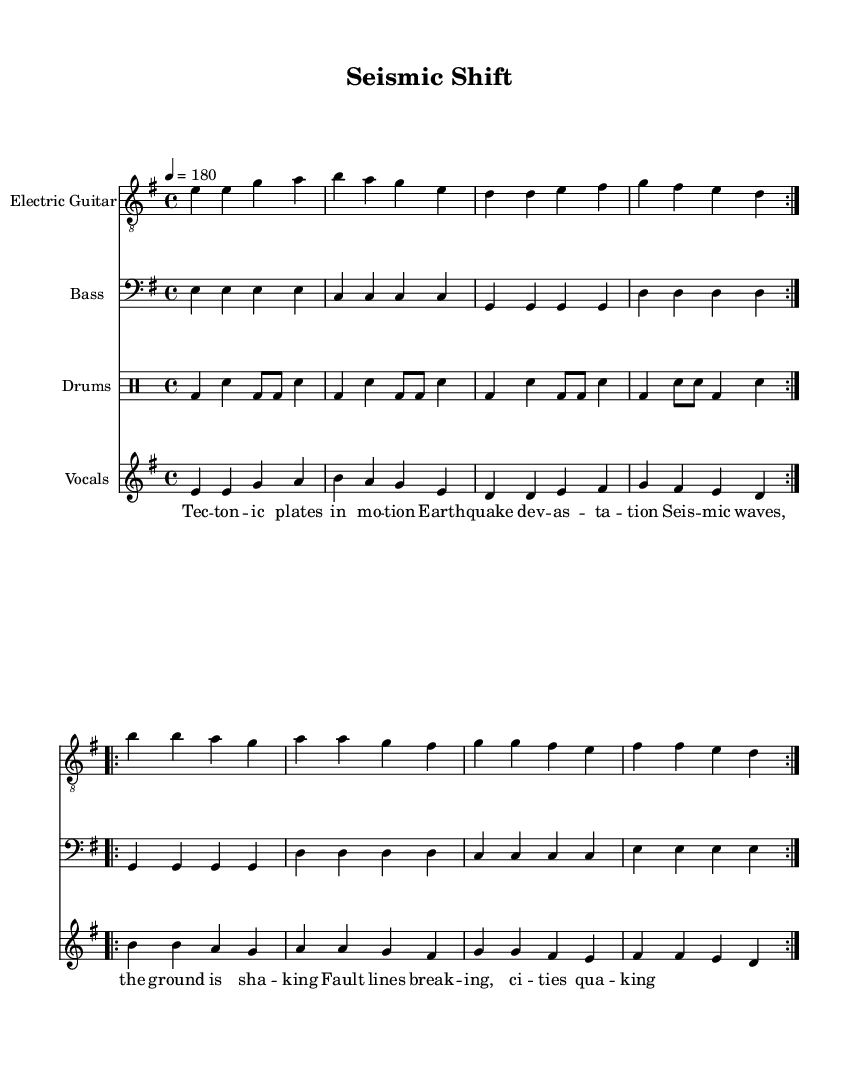what is the key signature of this music? The key signature is indicated at the beginning of the staff and consists of one sharp (F#), which defines it as E minor.
Answer: E minor what is the time signature of this music? The time signature is displayed at the beginning of the music, indicating that there are four beats per measure. It is shown as 4/4.
Answer: 4/4 what is the tempo marking of this song? The tempo marking is specified using a number indicating that there are 180 beats per minute, which conveys a fast, energetic pace.
Answer: 180 how many times is the first guitar section repeated? The music indicates a repeat sign followed by "volta," which means this section is repeated twice, affecting all parts of the guitar music.
Answer: 2 what instruments are included in this piece? The music lists three distinct parts indicating they are for Electric Guitar, Bass, and Drums, outlining a characteristic punk band setup.
Answer: Electric Guitar, Bass, Drums what themes are explored in the lyrics of this song? The lyrics are about geological phenomena, specifically tectonic activity and earthquakes, characterized by terms like "tectonic plates" and "earthquake devastation."
Answer: Natural disasters, geological phenomena how does the rhythm change in the drum part? In the drum section, the rhythm pattern alternates between bass drum and snare drum strikes, contributing to the driving intensity and diverse rhythmic structure typical in punk music.
Answer: Alternating bass and snare patterns 